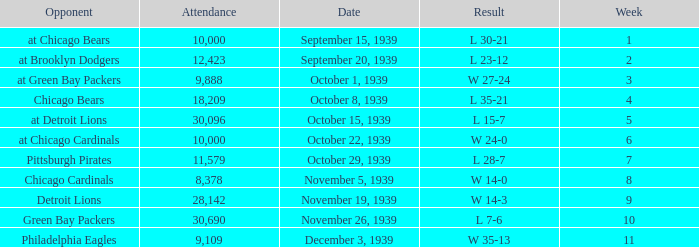What sum of Attendance has a Week smaller than 10, and a Result of l 30-21? 10000.0. 